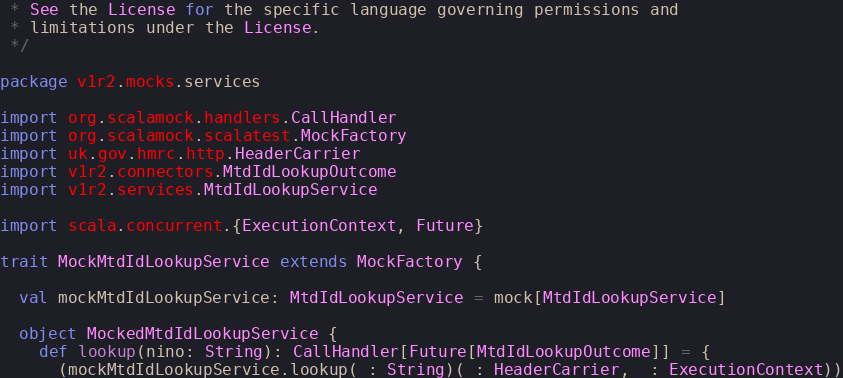<code> <loc_0><loc_0><loc_500><loc_500><_Scala_> * See the License for the specific language governing permissions and
 * limitations under the License.
 */

package v1r2.mocks.services

import org.scalamock.handlers.CallHandler
import org.scalamock.scalatest.MockFactory
import uk.gov.hmrc.http.HeaderCarrier
import v1r2.connectors.MtdIdLookupOutcome
import v1r2.services.MtdIdLookupService

import scala.concurrent.{ExecutionContext, Future}

trait MockMtdIdLookupService extends MockFactory {

  val mockMtdIdLookupService: MtdIdLookupService = mock[MtdIdLookupService]

  object MockedMtdIdLookupService {
    def lookup(nino: String): CallHandler[Future[MtdIdLookupOutcome]] = {
      (mockMtdIdLookupService.lookup(_: String)(_: HeaderCarrier, _: ExecutionContext))</code> 